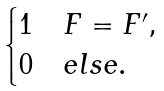<formula> <loc_0><loc_0><loc_500><loc_500>\begin{cases} 1 & F = F ^ { \prime } , \\ 0 & e l s e . \end{cases}</formula> 